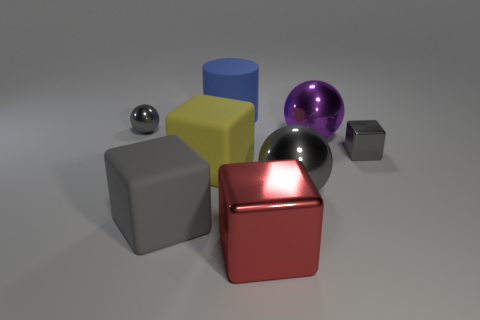Add 1 big purple things. How many objects exist? 9 Subtract all balls. How many objects are left? 5 Subtract 0 brown cylinders. How many objects are left? 8 Subtract all purple metallic objects. Subtract all large metallic spheres. How many objects are left? 5 Add 7 purple shiny objects. How many purple shiny objects are left? 8 Add 8 big blue objects. How many big blue objects exist? 9 